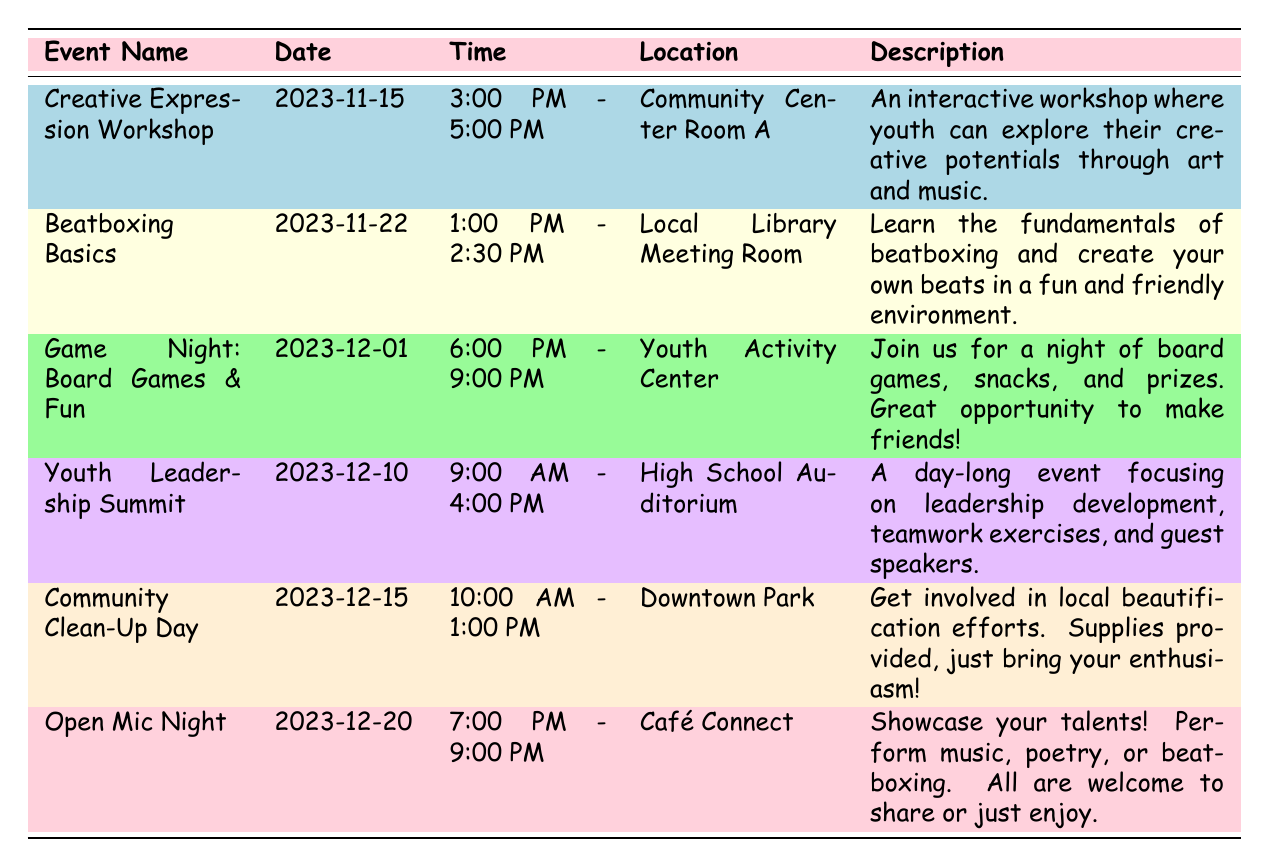What is the date of the "Community Clean-Up Day"? The table lists the "Community Clean-Up Day" under the event name column, and the corresponding date is found in the date column right next to it. The event date is 2023-12-15.
Answer: 2023-12-15 Where is the "Open Mic Night" being held? The "Open Mic Night" event in the table shows the location listed next to it. According to the table, it is being held at "Café Connect."
Answer: Café Connect How many workshops and events are scheduled in total? By counting the number of rows in the event name column, there are a total of 6 different workshops and events listed. Each row represents a unique event.
Answer: 6 What time does the "Beatboxing Basics" workshop start? The start time for the "Beatboxing Basics" event is located in the time column next to its name in the table. The time listed is 1:00 PM.
Answer: 1:00 PM Is there a youth engagement event scheduled on December 10, 2023? By checking the date column, December 10, 2023, corresponds with the "Youth Leadership Summit" event. Therefore, there is indeed a scheduled event on that date.
Answer: Yes Which event lasts the longest? To determine which event lasts the longest, we look at the time for each event and calculate their durations. The longest event is the "Youth Leadership Summit," lasting 7 hours.
Answer: Youth Leadership Summit How many events take place before December 15, 2023? By reviewing the dates in the table, the events that occur before December 15, 2023, are "Creative Expression Workshop," "Beatboxing Basics," "Game Night," and "Youth Leadership Summit," which totals to 4 events.
Answer: 4 What is the main focus of the "Youth Leadership Summit"? The table contains a description of the "Youth Leadership Summit," indicating that its focus is on leadership development, teamwork exercises, and guest speakers.
Answer: Leadership development, teamwork exercises, and guest speakers Are there any events that include creative arts? By examining the description of each event, both the "Creative Expression Workshop" and "Open Mic Night" include elements of creative arts. Hence, the answer is yes, there are events related to creative arts.
Answer: Yes What event occurs after "Game Night: Board Games & Fun"? The event that follows "Game Night" in the date sequence can be found by looking at the dates. According to the table, the next event is the "Youth Leadership Summit" on December 10, 2023.
Answer: Youth Leadership Summit 